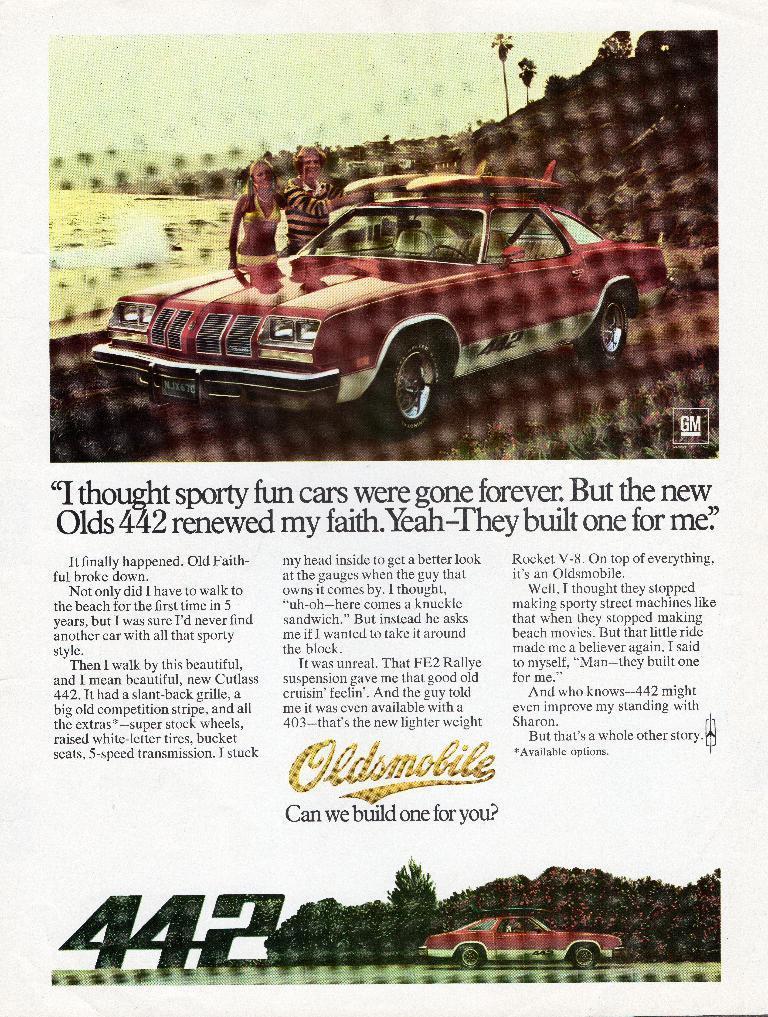Could you give a brief overview of what you see in this image? This looks like a paper. I think this is a picture of a car and two people standing near the seashore. This looks like a hill. These are the trees and houses. This is the water. I can see the letters on the paper. 